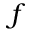<formula> <loc_0><loc_0><loc_500><loc_500>f</formula> 